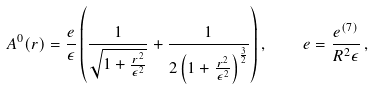<formula> <loc_0><loc_0><loc_500><loc_500>A ^ { 0 } ( r ) = \frac { e } { \epsilon } \left ( \frac { 1 } { \sqrt { 1 + \frac { r ^ { 2 } } { \epsilon ^ { 2 } } } } + \frac { 1 } { 2 \left ( 1 + \frac { r ^ { 2 } } { \epsilon ^ { 2 } } \right ) ^ { \frac { 3 } { 2 } } } \right ) , \quad e = \frac { e ^ { ( 7 ) } } { R ^ { 2 } \epsilon } \, ,</formula> 